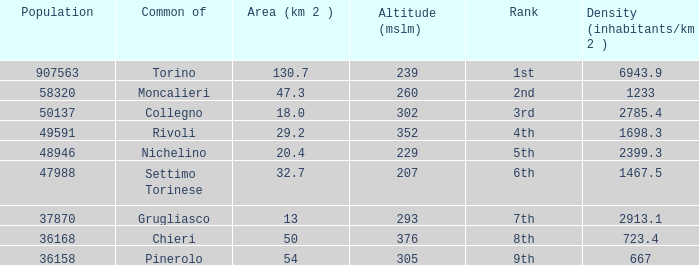The common of Chieri has what population density? 723.4. 